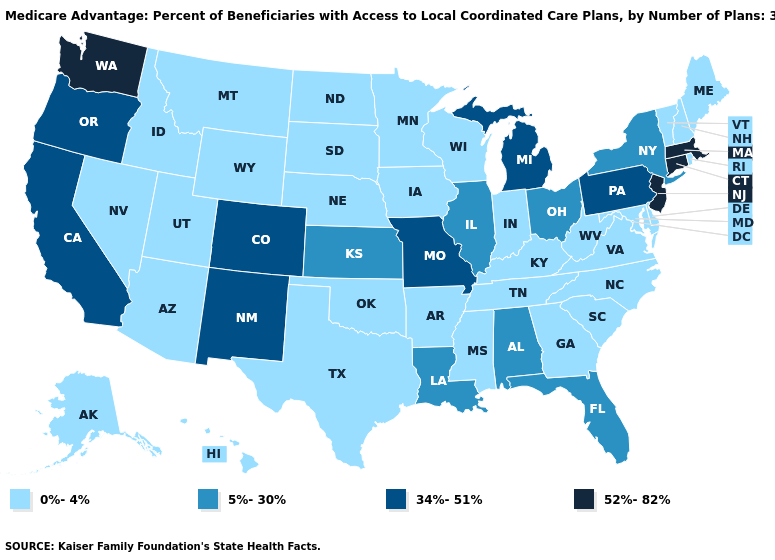How many symbols are there in the legend?
Concise answer only. 4. What is the value of West Virginia?
Answer briefly. 0%-4%. Name the states that have a value in the range 0%-4%?
Be succinct. Alaska, Arkansas, Arizona, Delaware, Georgia, Hawaii, Iowa, Idaho, Indiana, Kentucky, Maryland, Maine, Minnesota, Mississippi, Montana, North Carolina, North Dakota, Nebraska, New Hampshire, Nevada, Oklahoma, Rhode Island, South Carolina, South Dakota, Tennessee, Texas, Utah, Virginia, Vermont, Wisconsin, West Virginia, Wyoming. What is the value of Colorado?
Concise answer only. 34%-51%. What is the value of Indiana?
Answer briefly. 0%-4%. Does Iowa have a higher value than New Jersey?
Write a very short answer. No. Name the states that have a value in the range 0%-4%?
Be succinct. Alaska, Arkansas, Arizona, Delaware, Georgia, Hawaii, Iowa, Idaho, Indiana, Kentucky, Maryland, Maine, Minnesota, Mississippi, Montana, North Carolina, North Dakota, Nebraska, New Hampshire, Nevada, Oklahoma, Rhode Island, South Carolina, South Dakota, Tennessee, Texas, Utah, Virginia, Vermont, Wisconsin, West Virginia, Wyoming. Name the states that have a value in the range 0%-4%?
Quick response, please. Alaska, Arkansas, Arizona, Delaware, Georgia, Hawaii, Iowa, Idaho, Indiana, Kentucky, Maryland, Maine, Minnesota, Mississippi, Montana, North Carolina, North Dakota, Nebraska, New Hampshire, Nevada, Oklahoma, Rhode Island, South Carolina, South Dakota, Tennessee, Texas, Utah, Virginia, Vermont, Wisconsin, West Virginia, Wyoming. Name the states that have a value in the range 5%-30%?
Keep it brief. Alabama, Florida, Illinois, Kansas, Louisiana, New York, Ohio. Which states have the lowest value in the USA?
Concise answer only. Alaska, Arkansas, Arizona, Delaware, Georgia, Hawaii, Iowa, Idaho, Indiana, Kentucky, Maryland, Maine, Minnesota, Mississippi, Montana, North Carolina, North Dakota, Nebraska, New Hampshire, Nevada, Oklahoma, Rhode Island, South Carolina, South Dakota, Tennessee, Texas, Utah, Virginia, Vermont, Wisconsin, West Virginia, Wyoming. Name the states that have a value in the range 34%-51%?
Be succinct. California, Colorado, Michigan, Missouri, New Mexico, Oregon, Pennsylvania. Does Rhode Island have the lowest value in the Northeast?
Be succinct. Yes. Does the first symbol in the legend represent the smallest category?
Give a very brief answer. Yes. Does Massachusetts have the highest value in the Northeast?
Keep it brief. Yes. Does the map have missing data?
Short answer required. No. 